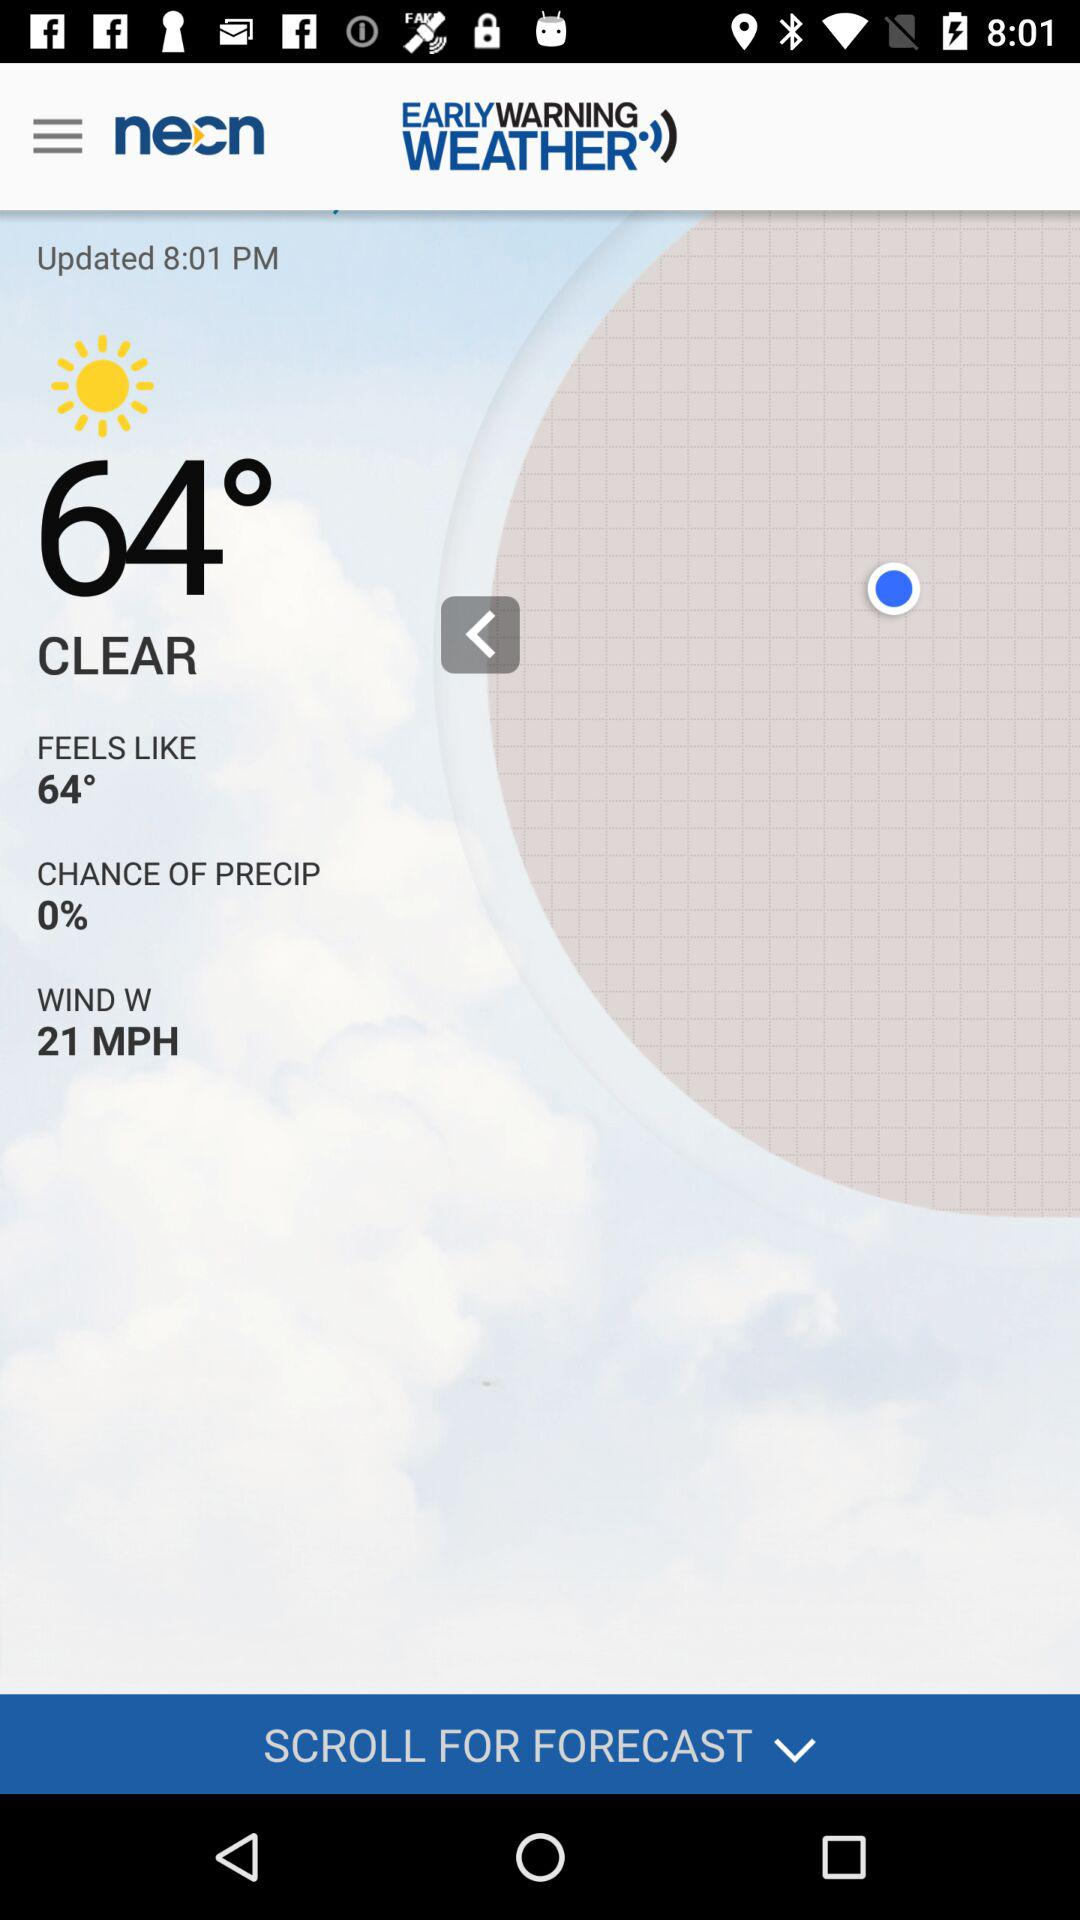When was it last updated? It was last updated at 8:01 PM. 